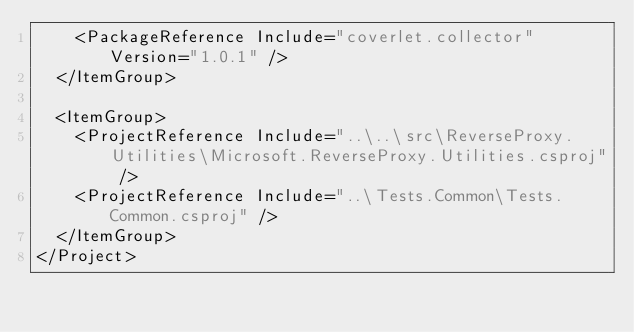<code> <loc_0><loc_0><loc_500><loc_500><_XML_>    <PackageReference Include="coverlet.collector" Version="1.0.1" />
  </ItemGroup>

  <ItemGroup>
    <ProjectReference Include="..\..\src\ReverseProxy.Utilities\Microsoft.ReverseProxy.Utilities.csproj" />
    <ProjectReference Include="..\Tests.Common\Tests.Common.csproj" />
  </ItemGroup>
</Project>
</code> 